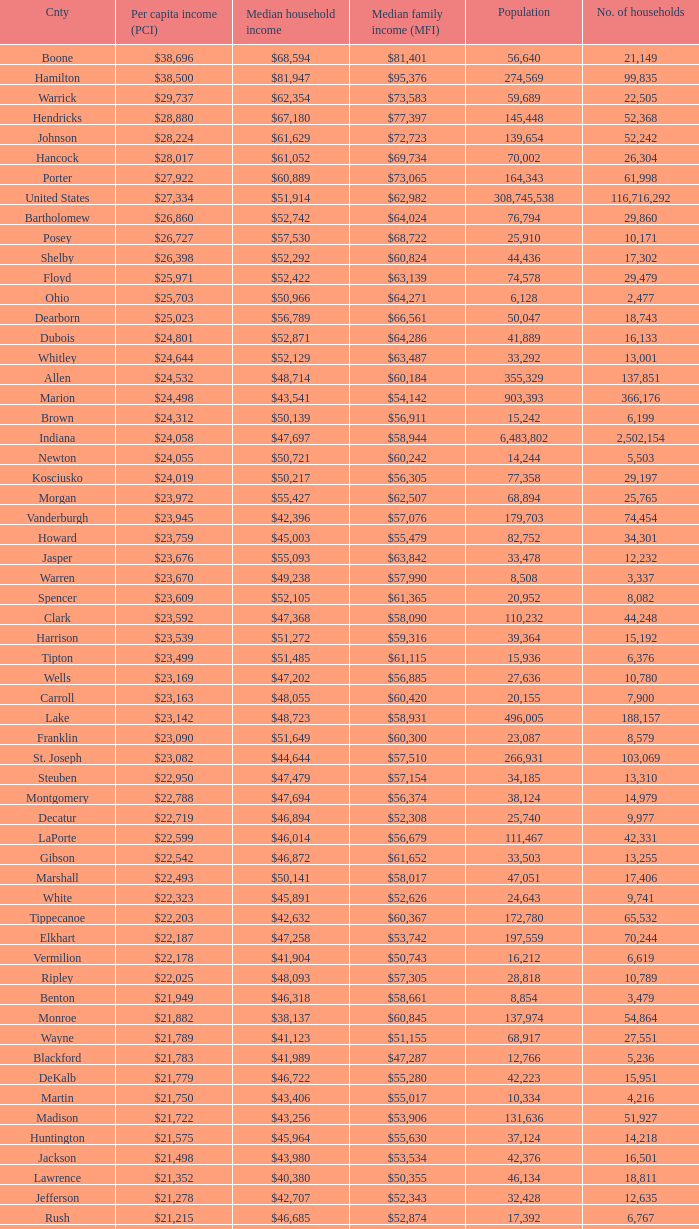What is the Median family income when the Median household income is $38,137? $60,845. 